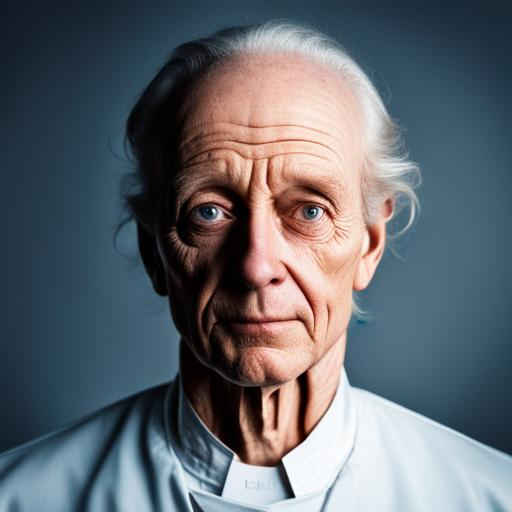What is the mood conveyed by the person's expression in this image? The person's expression appears solemn and contemplative, suggesting a moment of introspection or seriousness. 